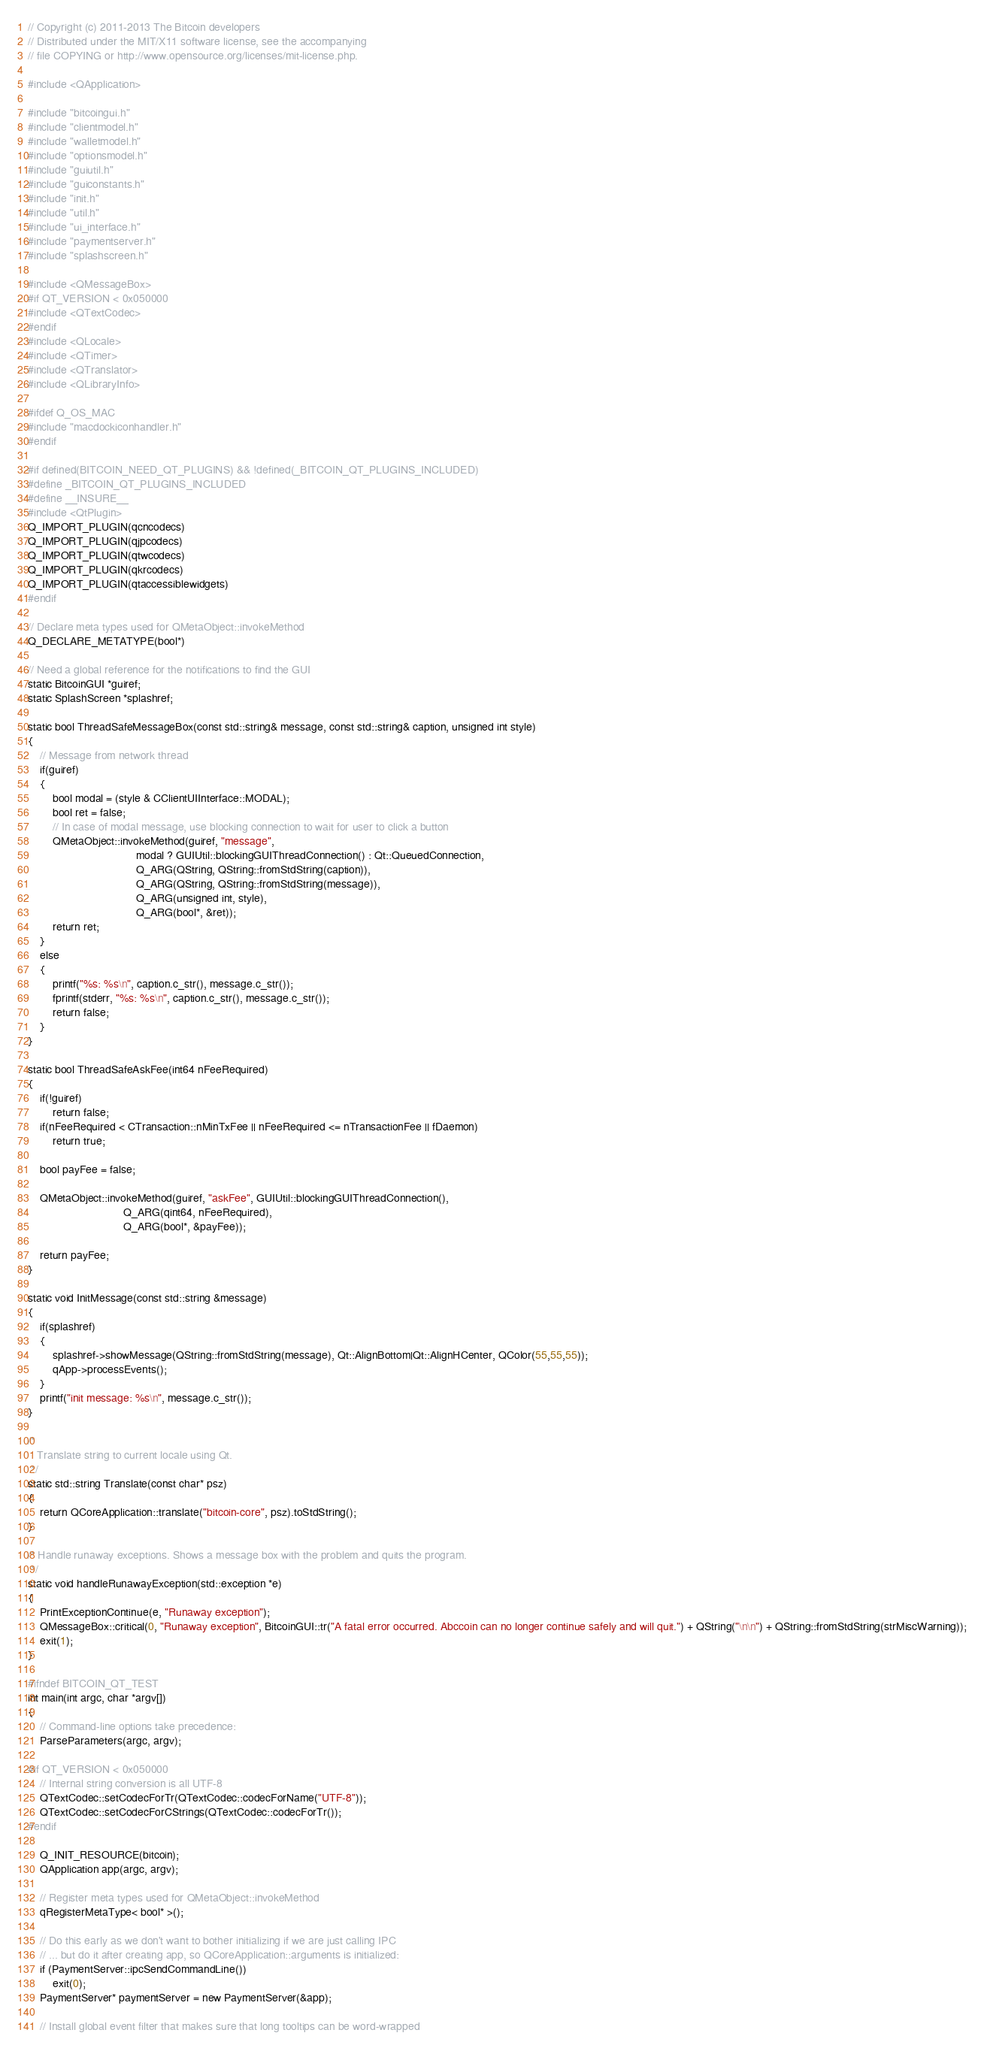<code> <loc_0><loc_0><loc_500><loc_500><_C++_>// Copyright (c) 2011-2013 The Bitcoin developers
// Distributed under the MIT/X11 software license, see the accompanying
// file COPYING or http://www.opensource.org/licenses/mit-license.php.

#include <QApplication>

#include "bitcoingui.h"
#include "clientmodel.h"
#include "walletmodel.h"
#include "optionsmodel.h"
#include "guiutil.h"
#include "guiconstants.h"
#include "init.h"
#include "util.h"
#include "ui_interface.h"
#include "paymentserver.h"
#include "splashscreen.h"

#include <QMessageBox>
#if QT_VERSION < 0x050000
#include <QTextCodec>
#endif
#include <QLocale>
#include <QTimer>
#include <QTranslator>
#include <QLibraryInfo>

#ifdef Q_OS_MAC
#include "macdockiconhandler.h"
#endif

#if defined(BITCOIN_NEED_QT_PLUGINS) && !defined(_BITCOIN_QT_PLUGINS_INCLUDED)
#define _BITCOIN_QT_PLUGINS_INCLUDED
#define __INSURE__
#include <QtPlugin>
Q_IMPORT_PLUGIN(qcncodecs)
Q_IMPORT_PLUGIN(qjpcodecs)
Q_IMPORT_PLUGIN(qtwcodecs)
Q_IMPORT_PLUGIN(qkrcodecs)
Q_IMPORT_PLUGIN(qtaccessiblewidgets)
#endif

// Declare meta types used for QMetaObject::invokeMethod
Q_DECLARE_METATYPE(bool*)

// Need a global reference for the notifications to find the GUI
static BitcoinGUI *guiref;
static SplashScreen *splashref;

static bool ThreadSafeMessageBox(const std::string& message, const std::string& caption, unsigned int style)
{
    // Message from network thread
    if(guiref)
    {
        bool modal = (style & CClientUIInterface::MODAL);
        bool ret = false;
        // In case of modal message, use blocking connection to wait for user to click a button
        QMetaObject::invokeMethod(guiref, "message",
                                   modal ? GUIUtil::blockingGUIThreadConnection() : Qt::QueuedConnection,
                                   Q_ARG(QString, QString::fromStdString(caption)),
                                   Q_ARG(QString, QString::fromStdString(message)),
                                   Q_ARG(unsigned int, style),
                                   Q_ARG(bool*, &ret));
        return ret;
    }
    else
    {
        printf("%s: %s\n", caption.c_str(), message.c_str());
        fprintf(stderr, "%s: %s\n", caption.c_str(), message.c_str());
        return false;
    }
}

static bool ThreadSafeAskFee(int64 nFeeRequired)
{
    if(!guiref)
        return false;
    if(nFeeRequired < CTransaction::nMinTxFee || nFeeRequired <= nTransactionFee || fDaemon)
        return true;

    bool payFee = false;

    QMetaObject::invokeMethod(guiref, "askFee", GUIUtil::blockingGUIThreadConnection(),
                               Q_ARG(qint64, nFeeRequired),
                               Q_ARG(bool*, &payFee));

    return payFee;
}

static void InitMessage(const std::string &message)
{
    if(splashref)
    {
        splashref->showMessage(QString::fromStdString(message), Qt::AlignBottom|Qt::AlignHCenter, QColor(55,55,55));
        qApp->processEvents();
    }
    printf("init message: %s\n", message.c_str());
}

/*
   Translate string to current locale using Qt.
 */
static std::string Translate(const char* psz)
{
    return QCoreApplication::translate("bitcoin-core", psz).toStdString();
}

/* Handle runaway exceptions. Shows a message box with the problem and quits the program.
 */
static void handleRunawayException(std::exception *e)
{
    PrintExceptionContinue(e, "Runaway exception");
    QMessageBox::critical(0, "Runaway exception", BitcoinGUI::tr("A fatal error occurred. Abccoin can no longer continue safely and will quit.") + QString("\n\n") + QString::fromStdString(strMiscWarning));
    exit(1);
}

#ifndef BITCOIN_QT_TEST
int main(int argc, char *argv[])
{
    // Command-line options take precedence:
    ParseParameters(argc, argv);

#if QT_VERSION < 0x050000
    // Internal string conversion is all UTF-8
    QTextCodec::setCodecForTr(QTextCodec::codecForName("UTF-8"));
    QTextCodec::setCodecForCStrings(QTextCodec::codecForTr());
#endif

    Q_INIT_RESOURCE(bitcoin);
    QApplication app(argc, argv);

    // Register meta types used for QMetaObject::invokeMethod
    qRegisterMetaType< bool* >();

    // Do this early as we don't want to bother initializing if we are just calling IPC
    // ... but do it after creating app, so QCoreApplication::arguments is initialized:
    if (PaymentServer::ipcSendCommandLine())
        exit(0);
    PaymentServer* paymentServer = new PaymentServer(&app);

    // Install global event filter that makes sure that long tooltips can be word-wrapped</code> 